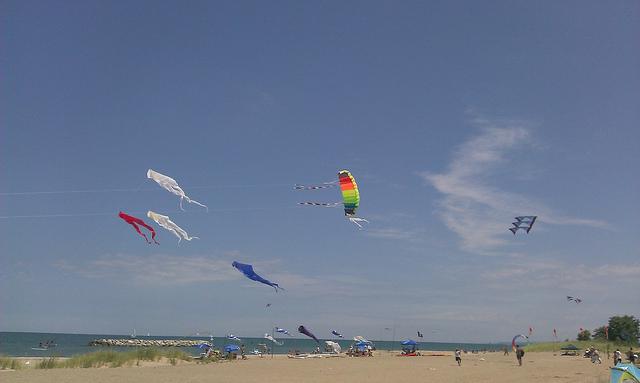How many colors are on the multicolor kite?
Concise answer only. 7. Is flying kites like these fun?
Short answer required. Yes. Is this picture taken in the mountains?
Give a very brief answer. No. Is there water in the background?
Keep it brief. Yes. What type of terrain is in the background?
Give a very brief answer. Beach. 